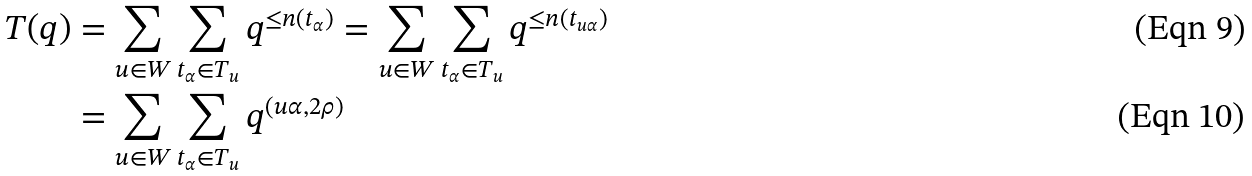<formula> <loc_0><loc_0><loc_500><loc_500>T ( q ) & = \sum _ { u \in W } \sum _ { t _ { \alpha } \in T _ { u } } q ^ { \leq n ( t _ { \alpha } ) } = \sum _ { u \in W } \sum _ { t _ { \alpha } \in T _ { u } } q ^ { \leq n ( t _ { u \alpha } ) } \\ & = \sum _ { u \in W } \sum _ { t _ { \alpha } \in T _ { u } } q ^ { ( u \alpha , 2 \rho ) }</formula> 